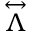<formula> <loc_0><loc_0><loc_500><loc_500>\overset { \leftrightarrow } \Lambda }</formula> 